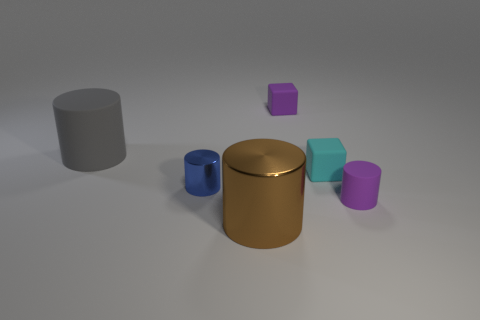Add 2 small objects. How many objects exist? 8 Subtract all cubes. How many objects are left? 4 Add 3 purple rubber cubes. How many purple rubber cubes are left? 4 Add 2 small cylinders. How many small cylinders exist? 4 Subtract 0 blue blocks. How many objects are left? 6 Subtract all matte cubes. Subtract all big brown shiny cylinders. How many objects are left? 3 